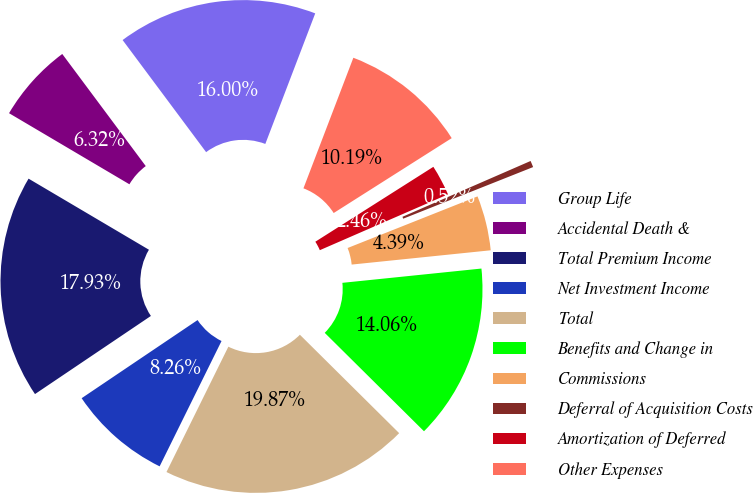<chart> <loc_0><loc_0><loc_500><loc_500><pie_chart><fcel>Group Life<fcel>Accidental Death &<fcel>Total Premium Income<fcel>Net Investment Income<fcel>Total<fcel>Benefits and Change in<fcel>Commissions<fcel>Deferral of Acquisition Costs<fcel>Amortization of Deferred<fcel>Other Expenses<nl><fcel>16.0%<fcel>6.32%<fcel>17.93%<fcel>8.26%<fcel>19.87%<fcel>14.06%<fcel>4.39%<fcel>0.52%<fcel>2.46%<fcel>10.19%<nl></chart> 